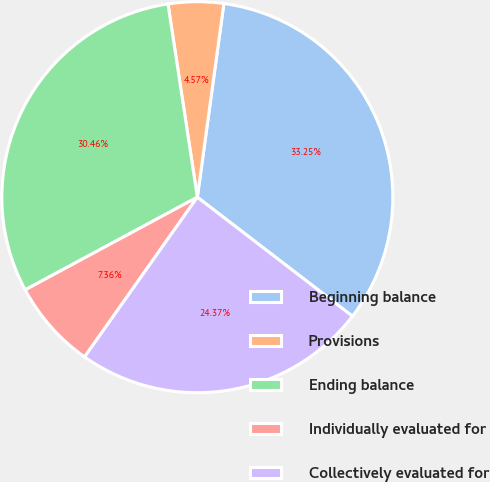Convert chart to OTSL. <chart><loc_0><loc_0><loc_500><loc_500><pie_chart><fcel>Beginning balance<fcel>Provisions<fcel>Ending balance<fcel>Individually evaluated for<fcel>Collectively evaluated for<nl><fcel>33.25%<fcel>4.57%<fcel>30.46%<fcel>7.36%<fcel>24.37%<nl></chart> 